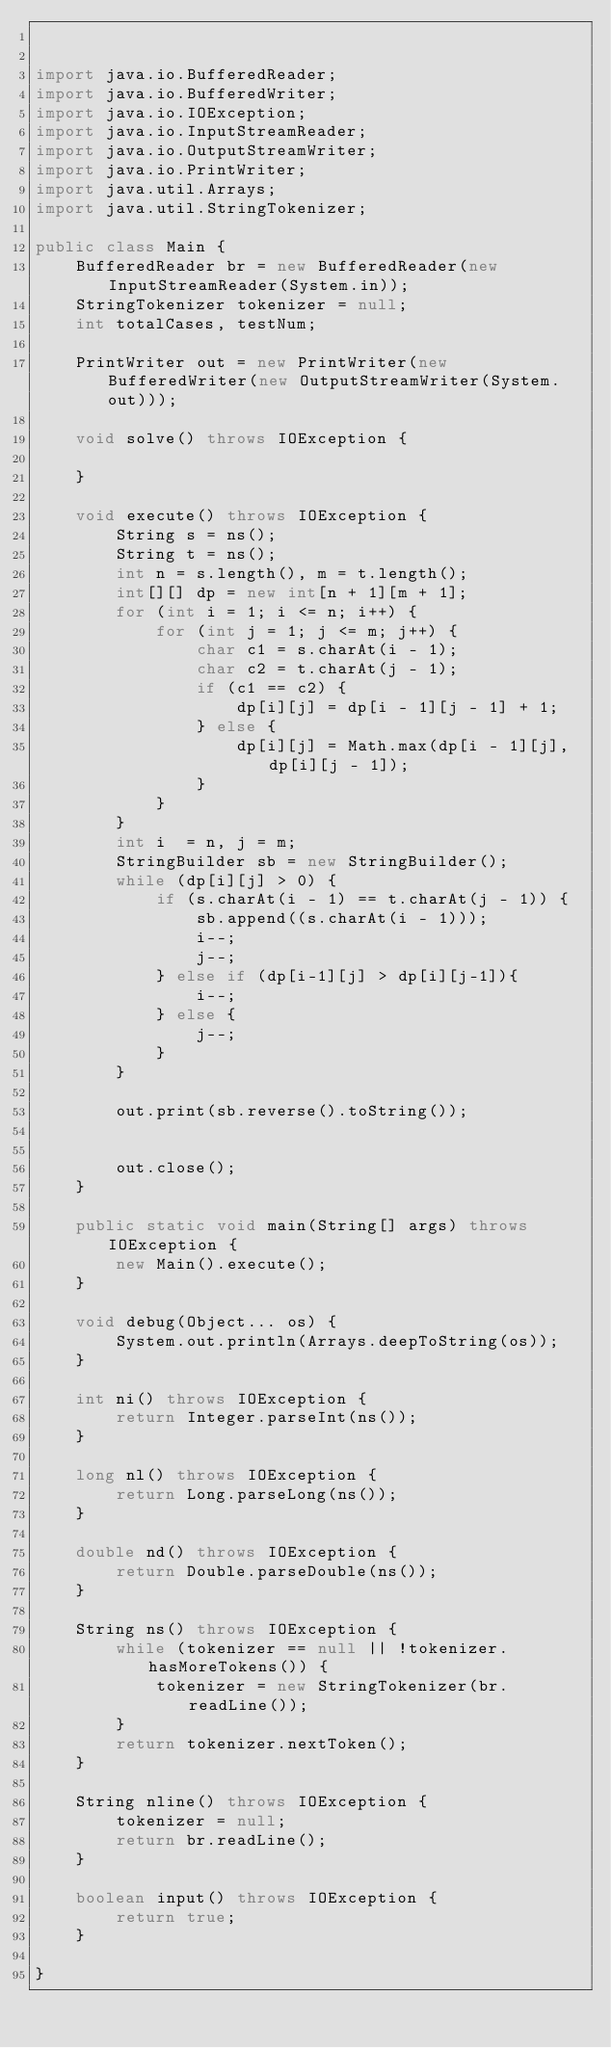<code> <loc_0><loc_0><loc_500><loc_500><_Java_>

import java.io.BufferedReader;
import java.io.BufferedWriter;
import java.io.IOException;
import java.io.InputStreamReader;
import java.io.OutputStreamWriter;
import java.io.PrintWriter;
import java.util.Arrays;
import java.util.StringTokenizer;

public class Main {
    BufferedReader br = new BufferedReader(new InputStreamReader(System.in));
    StringTokenizer tokenizer = null;
    int totalCases, testNum;

    PrintWriter out = new PrintWriter(new BufferedWriter(new OutputStreamWriter(System.out)));

    void solve() throws IOException {

    }

    void execute() throws IOException {
        String s = ns();
        String t = ns();
        int n = s.length(), m = t.length();
        int[][] dp = new int[n + 1][m + 1];
        for (int i = 1; i <= n; i++) {
            for (int j = 1; j <= m; j++) {
                char c1 = s.charAt(i - 1);
                char c2 = t.charAt(j - 1);
                if (c1 == c2) {
                    dp[i][j] = dp[i - 1][j - 1] + 1;
                } else {
                    dp[i][j] = Math.max(dp[i - 1][j], dp[i][j - 1]);
                }
            }
        }
        int i  = n, j = m;
        StringBuilder sb = new StringBuilder();
        while (dp[i][j] > 0) {
            if (s.charAt(i - 1) == t.charAt(j - 1)) {
                sb.append((s.charAt(i - 1)));
                i--;
                j--;
            } else if (dp[i-1][j] > dp[i][j-1]){
                i--;
            } else {
                j--;
            }
        }

        out.print(sb.reverse().toString());


        out.close();
    }

    public static void main(String[] args) throws IOException {
        new Main().execute();
    }

    void debug(Object... os) {
        System.out.println(Arrays.deepToString(os));
    }

    int ni() throws IOException {
        return Integer.parseInt(ns());
    }

    long nl() throws IOException {
        return Long.parseLong(ns());
    }

    double nd() throws IOException {
        return Double.parseDouble(ns());
    }

    String ns() throws IOException {
        while (tokenizer == null || !tokenizer.hasMoreTokens()) {
            tokenizer = new StringTokenizer(br.readLine());
        }
        return tokenizer.nextToken();
    }

    String nline() throws IOException {
        tokenizer = null;
        return br.readLine();
    }

    boolean input() throws IOException {
        return true;
    }

}
</code> 